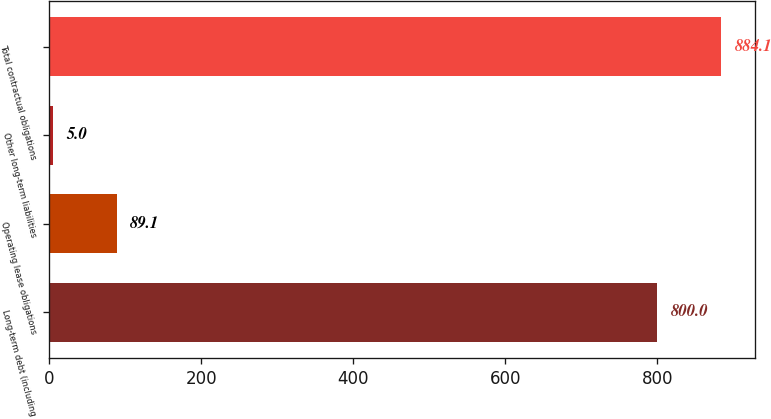Convert chart. <chart><loc_0><loc_0><loc_500><loc_500><bar_chart><fcel>Long-term debt (including<fcel>Operating lease obligations<fcel>Other long-term liabilities<fcel>Total contractual obligations<nl><fcel>800<fcel>89.1<fcel>5<fcel>884.1<nl></chart> 